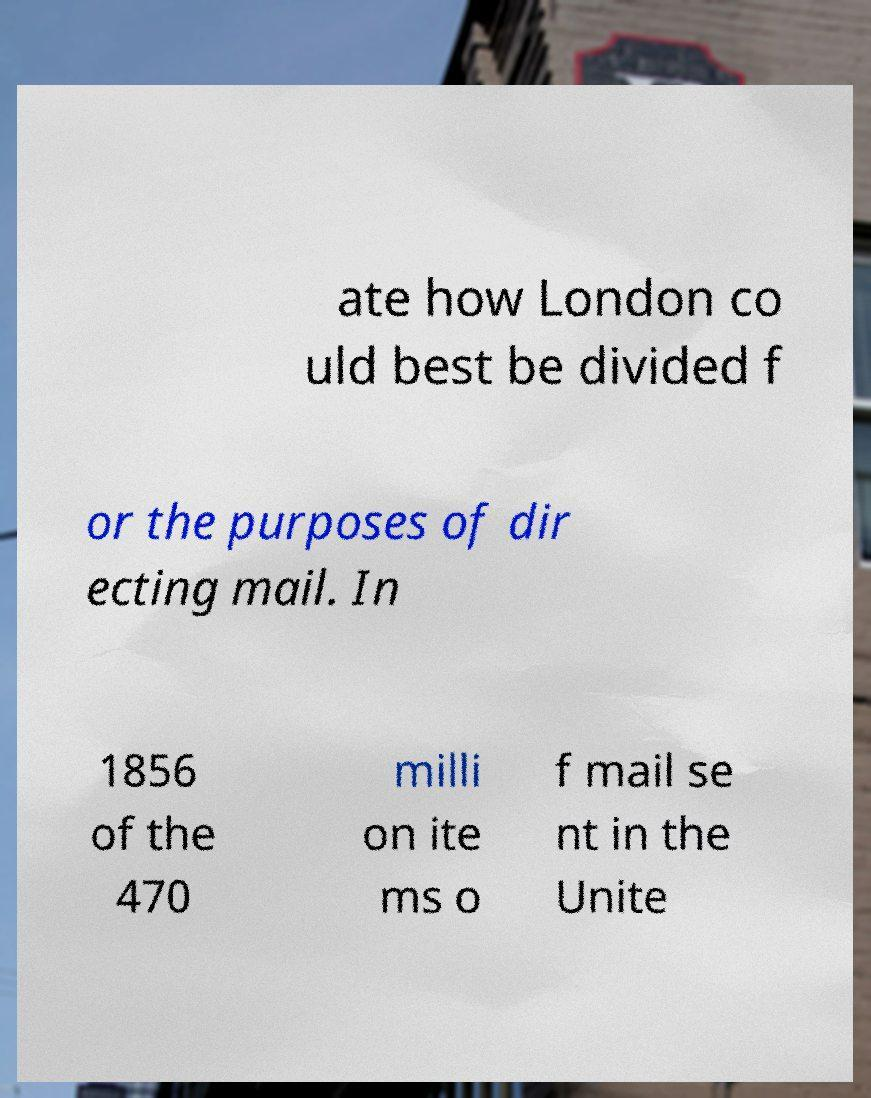I need the written content from this picture converted into text. Can you do that? ate how London co uld best be divided f or the purposes of dir ecting mail. In 1856 of the 470 milli on ite ms o f mail se nt in the Unite 